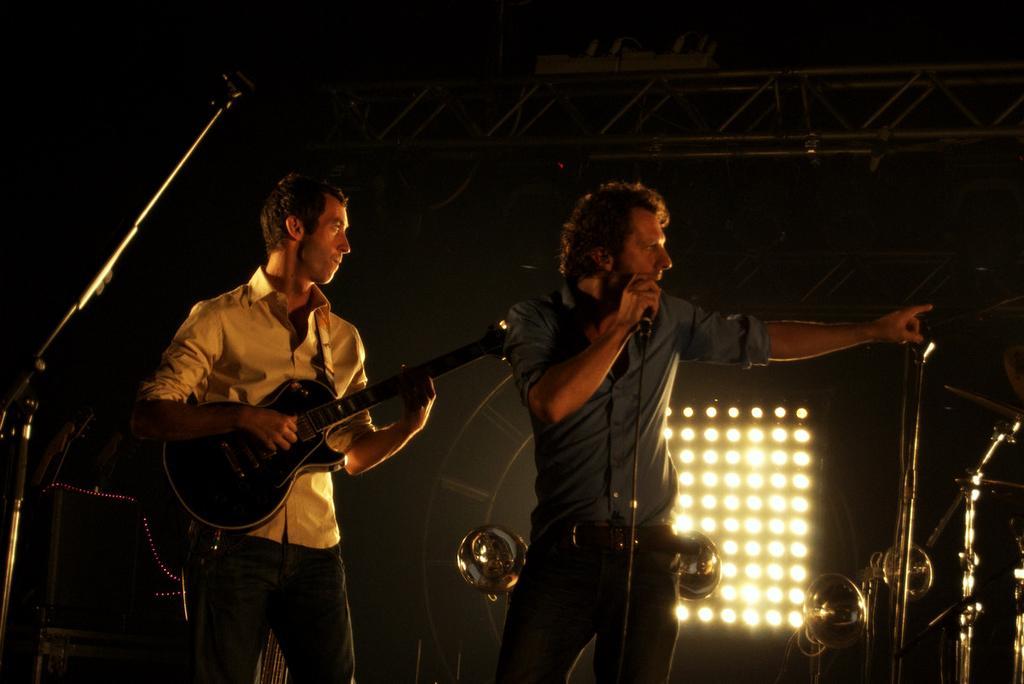Could you give a brief overview of what you see in this image? In this image I can see two men are standing where one is holding a mic and one is holding a guitar. In the background I can see few more mics and few lights. 